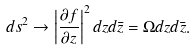Convert formula to latex. <formula><loc_0><loc_0><loc_500><loc_500>d s ^ { 2 } \rightarrow \left | \frac { \partial f } { \partial z } \right | ^ { 2 } d z d \bar { z } = \Omega d z d \bar { z } .</formula> 